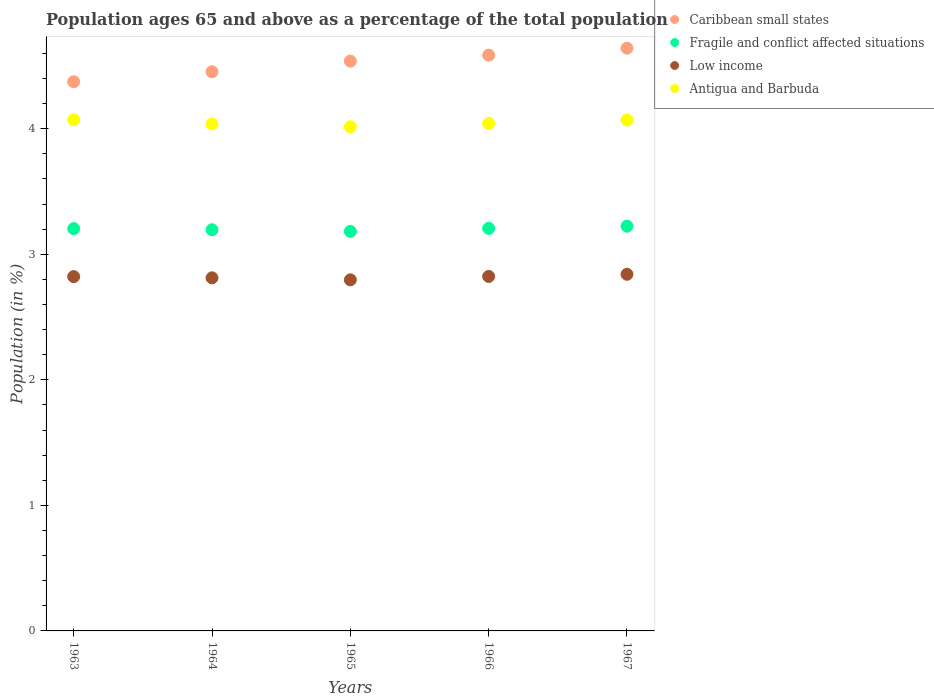How many different coloured dotlines are there?
Make the answer very short. 4. Is the number of dotlines equal to the number of legend labels?
Your answer should be compact. Yes. What is the percentage of the population ages 65 and above in Fragile and conflict affected situations in 1966?
Provide a succinct answer. 3.21. Across all years, what is the maximum percentage of the population ages 65 and above in Low income?
Your answer should be very brief. 2.84. Across all years, what is the minimum percentage of the population ages 65 and above in Caribbean small states?
Offer a terse response. 4.37. In which year was the percentage of the population ages 65 and above in Fragile and conflict affected situations maximum?
Your answer should be very brief. 1967. In which year was the percentage of the population ages 65 and above in Antigua and Barbuda minimum?
Provide a short and direct response. 1965. What is the total percentage of the population ages 65 and above in Caribbean small states in the graph?
Make the answer very short. 22.59. What is the difference between the percentage of the population ages 65 and above in Fragile and conflict affected situations in 1963 and that in 1966?
Provide a short and direct response. -0. What is the difference between the percentage of the population ages 65 and above in Caribbean small states in 1966 and the percentage of the population ages 65 and above in Fragile and conflict affected situations in 1965?
Offer a terse response. 1.4. What is the average percentage of the population ages 65 and above in Low income per year?
Keep it short and to the point. 2.82. In the year 1966, what is the difference between the percentage of the population ages 65 and above in Caribbean small states and percentage of the population ages 65 and above in Fragile and conflict affected situations?
Ensure brevity in your answer.  1.38. In how many years, is the percentage of the population ages 65 and above in Antigua and Barbuda greater than 3.2?
Your response must be concise. 5. What is the ratio of the percentage of the population ages 65 and above in Antigua and Barbuda in 1963 to that in 1967?
Provide a short and direct response. 1. Is the percentage of the population ages 65 and above in Fragile and conflict affected situations in 1964 less than that in 1966?
Keep it short and to the point. Yes. What is the difference between the highest and the second highest percentage of the population ages 65 and above in Caribbean small states?
Your response must be concise. 0.06. What is the difference between the highest and the lowest percentage of the population ages 65 and above in Fragile and conflict affected situations?
Your response must be concise. 0.04. In how many years, is the percentage of the population ages 65 and above in Low income greater than the average percentage of the population ages 65 and above in Low income taken over all years?
Provide a short and direct response. 3. Is the sum of the percentage of the population ages 65 and above in Fragile and conflict affected situations in 1964 and 1965 greater than the maximum percentage of the population ages 65 and above in Antigua and Barbuda across all years?
Provide a succinct answer. Yes. Is it the case that in every year, the sum of the percentage of the population ages 65 and above in Fragile and conflict affected situations and percentage of the population ages 65 and above in Antigua and Barbuda  is greater than the percentage of the population ages 65 and above in Caribbean small states?
Make the answer very short. Yes. Is the percentage of the population ages 65 and above in Fragile and conflict affected situations strictly greater than the percentage of the population ages 65 and above in Caribbean small states over the years?
Make the answer very short. No. Is the percentage of the population ages 65 and above in Caribbean small states strictly less than the percentage of the population ages 65 and above in Antigua and Barbuda over the years?
Your answer should be very brief. No. Are the values on the major ticks of Y-axis written in scientific E-notation?
Provide a succinct answer. No. Does the graph contain grids?
Your answer should be compact. No. Where does the legend appear in the graph?
Offer a terse response. Top right. How many legend labels are there?
Your answer should be very brief. 4. What is the title of the graph?
Your answer should be compact. Population ages 65 and above as a percentage of the total population. What is the label or title of the X-axis?
Provide a short and direct response. Years. What is the Population (in %) in Caribbean small states in 1963?
Provide a succinct answer. 4.37. What is the Population (in %) of Fragile and conflict affected situations in 1963?
Give a very brief answer. 3.2. What is the Population (in %) in Low income in 1963?
Provide a succinct answer. 2.82. What is the Population (in %) in Antigua and Barbuda in 1963?
Your answer should be compact. 4.07. What is the Population (in %) in Caribbean small states in 1964?
Offer a terse response. 4.45. What is the Population (in %) in Fragile and conflict affected situations in 1964?
Provide a succinct answer. 3.2. What is the Population (in %) of Low income in 1964?
Keep it short and to the point. 2.81. What is the Population (in %) of Antigua and Barbuda in 1964?
Offer a very short reply. 4.04. What is the Population (in %) in Caribbean small states in 1965?
Give a very brief answer. 4.54. What is the Population (in %) in Fragile and conflict affected situations in 1965?
Make the answer very short. 3.18. What is the Population (in %) in Low income in 1965?
Your answer should be very brief. 2.8. What is the Population (in %) in Antigua and Barbuda in 1965?
Ensure brevity in your answer.  4.01. What is the Population (in %) in Caribbean small states in 1966?
Provide a short and direct response. 4.59. What is the Population (in %) of Fragile and conflict affected situations in 1966?
Give a very brief answer. 3.21. What is the Population (in %) in Low income in 1966?
Offer a very short reply. 2.82. What is the Population (in %) of Antigua and Barbuda in 1966?
Your response must be concise. 4.04. What is the Population (in %) in Caribbean small states in 1967?
Keep it short and to the point. 4.64. What is the Population (in %) in Fragile and conflict affected situations in 1967?
Offer a very short reply. 3.22. What is the Population (in %) of Low income in 1967?
Keep it short and to the point. 2.84. What is the Population (in %) in Antigua and Barbuda in 1967?
Make the answer very short. 4.07. Across all years, what is the maximum Population (in %) in Caribbean small states?
Offer a terse response. 4.64. Across all years, what is the maximum Population (in %) of Fragile and conflict affected situations?
Your answer should be very brief. 3.22. Across all years, what is the maximum Population (in %) in Low income?
Ensure brevity in your answer.  2.84. Across all years, what is the maximum Population (in %) in Antigua and Barbuda?
Your response must be concise. 4.07. Across all years, what is the minimum Population (in %) of Caribbean small states?
Keep it short and to the point. 4.37. Across all years, what is the minimum Population (in %) of Fragile and conflict affected situations?
Ensure brevity in your answer.  3.18. Across all years, what is the minimum Population (in %) in Low income?
Ensure brevity in your answer.  2.8. Across all years, what is the minimum Population (in %) in Antigua and Barbuda?
Provide a short and direct response. 4.01. What is the total Population (in %) of Caribbean small states in the graph?
Make the answer very short. 22.59. What is the total Population (in %) in Fragile and conflict affected situations in the graph?
Offer a terse response. 16.01. What is the total Population (in %) in Low income in the graph?
Keep it short and to the point. 14.09. What is the total Population (in %) of Antigua and Barbuda in the graph?
Your answer should be compact. 20.23. What is the difference between the Population (in %) of Caribbean small states in 1963 and that in 1964?
Provide a short and direct response. -0.08. What is the difference between the Population (in %) of Fragile and conflict affected situations in 1963 and that in 1964?
Offer a terse response. 0.01. What is the difference between the Population (in %) of Low income in 1963 and that in 1964?
Give a very brief answer. 0.01. What is the difference between the Population (in %) in Antigua and Barbuda in 1963 and that in 1964?
Ensure brevity in your answer.  0.03. What is the difference between the Population (in %) in Caribbean small states in 1963 and that in 1965?
Your response must be concise. -0.16. What is the difference between the Population (in %) of Fragile and conflict affected situations in 1963 and that in 1965?
Offer a very short reply. 0.02. What is the difference between the Population (in %) of Low income in 1963 and that in 1965?
Provide a succinct answer. 0.03. What is the difference between the Population (in %) in Antigua and Barbuda in 1963 and that in 1965?
Provide a short and direct response. 0.06. What is the difference between the Population (in %) of Caribbean small states in 1963 and that in 1966?
Your answer should be compact. -0.21. What is the difference between the Population (in %) in Fragile and conflict affected situations in 1963 and that in 1966?
Keep it short and to the point. -0. What is the difference between the Population (in %) of Low income in 1963 and that in 1966?
Make the answer very short. -0. What is the difference between the Population (in %) of Antigua and Barbuda in 1963 and that in 1966?
Offer a terse response. 0.03. What is the difference between the Population (in %) in Caribbean small states in 1963 and that in 1967?
Your response must be concise. -0.27. What is the difference between the Population (in %) in Fragile and conflict affected situations in 1963 and that in 1967?
Make the answer very short. -0.02. What is the difference between the Population (in %) of Low income in 1963 and that in 1967?
Provide a succinct answer. -0.02. What is the difference between the Population (in %) of Caribbean small states in 1964 and that in 1965?
Offer a very short reply. -0.08. What is the difference between the Population (in %) of Fragile and conflict affected situations in 1964 and that in 1965?
Provide a succinct answer. 0.01. What is the difference between the Population (in %) of Low income in 1964 and that in 1965?
Provide a succinct answer. 0.02. What is the difference between the Population (in %) in Antigua and Barbuda in 1964 and that in 1965?
Offer a terse response. 0.02. What is the difference between the Population (in %) in Caribbean small states in 1964 and that in 1966?
Make the answer very short. -0.13. What is the difference between the Population (in %) of Fragile and conflict affected situations in 1964 and that in 1966?
Give a very brief answer. -0.01. What is the difference between the Population (in %) of Low income in 1964 and that in 1966?
Your response must be concise. -0.01. What is the difference between the Population (in %) of Antigua and Barbuda in 1964 and that in 1966?
Ensure brevity in your answer.  -0. What is the difference between the Population (in %) of Caribbean small states in 1964 and that in 1967?
Your answer should be very brief. -0.19. What is the difference between the Population (in %) in Fragile and conflict affected situations in 1964 and that in 1967?
Provide a succinct answer. -0.03. What is the difference between the Population (in %) in Low income in 1964 and that in 1967?
Make the answer very short. -0.03. What is the difference between the Population (in %) in Antigua and Barbuda in 1964 and that in 1967?
Give a very brief answer. -0.03. What is the difference between the Population (in %) in Caribbean small states in 1965 and that in 1966?
Ensure brevity in your answer.  -0.05. What is the difference between the Population (in %) in Fragile and conflict affected situations in 1965 and that in 1966?
Offer a terse response. -0.02. What is the difference between the Population (in %) of Low income in 1965 and that in 1966?
Your response must be concise. -0.03. What is the difference between the Population (in %) of Antigua and Barbuda in 1965 and that in 1966?
Your response must be concise. -0.03. What is the difference between the Population (in %) in Caribbean small states in 1965 and that in 1967?
Keep it short and to the point. -0.1. What is the difference between the Population (in %) of Fragile and conflict affected situations in 1965 and that in 1967?
Make the answer very short. -0.04. What is the difference between the Population (in %) of Low income in 1965 and that in 1967?
Your answer should be very brief. -0.04. What is the difference between the Population (in %) of Antigua and Barbuda in 1965 and that in 1967?
Provide a short and direct response. -0.05. What is the difference between the Population (in %) of Caribbean small states in 1966 and that in 1967?
Your answer should be very brief. -0.06. What is the difference between the Population (in %) in Fragile and conflict affected situations in 1966 and that in 1967?
Provide a succinct answer. -0.02. What is the difference between the Population (in %) in Low income in 1966 and that in 1967?
Offer a very short reply. -0.02. What is the difference between the Population (in %) in Antigua and Barbuda in 1966 and that in 1967?
Give a very brief answer. -0.03. What is the difference between the Population (in %) in Caribbean small states in 1963 and the Population (in %) in Fragile and conflict affected situations in 1964?
Give a very brief answer. 1.18. What is the difference between the Population (in %) of Caribbean small states in 1963 and the Population (in %) of Low income in 1964?
Keep it short and to the point. 1.56. What is the difference between the Population (in %) in Caribbean small states in 1963 and the Population (in %) in Antigua and Barbuda in 1964?
Provide a short and direct response. 0.34. What is the difference between the Population (in %) in Fragile and conflict affected situations in 1963 and the Population (in %) in Low income in 1964?
Your response must be concise. 0.39. What is the difference between the Population (in %) in Fragile and conflict affected situations in 1963 and the Population (in %) in Antigua and Barbuda in 1964?
Your response must be concise. -0.83. What is the difference between the Population (in %) of Low income in 1963 and the Population (in %) of Antigua and Barbuda in 1964?
Make the answer very short. -1.22. What is the difference between the Population (in %) in Caribbean small states in 1963 and the Population (in %) in Fragile and conflict affected situations in 1965?
Keep it short and to the point. 1.19. What is the difference between the Population (in %) of Caribbean small states in 1963 and the Population (in %) of Low income in 1965?
Make the answer very short. 1.58. What is the difference between the Population (in %) of Caribbean small states in 1963 and the Population (in %) of Antigua and Barbuda in 1965?
Keep it short and to the point. 0.36. What is the difference between the Population (in %) of Fragile and conflict affected situations in 1963 and the Population (in %) of Low income in 1965?
Provide a succinct answer. 0.41. What is the difference between the Population (in %) of Fragile and conflict affected situations in 1963 and the Population (in %) of Antigua and Barbuda in 1965?
Provide a succinct answer. -0.81. What is the difference between the Population (in %) of Low income in 1963 and the Population (in %) of Antigua and Barbuda in 1965?
Keep it short and to the point. -1.19. What is the difference between the Population (in %) in Caribbean small states in 1963 and the Population (in %) in Fragile and conflict affected situations in 1966?
Keep it short and to the point. 1.17. What is the difference between the Population (in %) of Caribbean small states in 1963 and the Population (in %) of Low income in 1966?
Provide a succinct answer. 1.55. What is the difference between the Population (in %) of Caribbean small states in 1963 and the Population (in %) of Antigua and Barbuda in 1966?
Your answer should be very brief. 0.33. What is the difference between the Population (in %) in Fragile and conflict affected situations in 1963 and the Population (in %) in Low income in 1966?
Your answer should be very brief. 0.38. What is the difference between the Population (in %) in Fragile and conflict affected situations in 1963 and the Population (in %) in Antigua and Barbuda in 1966?
Make the answer very short. -0.84. What is the difference between the Population (in %) in Low income in 1963 and the Population (in %) in Antigua and Barbuda in 1966?
Give a very brief answer. -1.22. What is the difference between the Population (in %) of Caribbean small states in 1963 and the Population (in %) of Fragile and conflict affected situations in 1967?
Provide a succinct answer. 1.15. What is the difference between the Population (in %) of Caribbean small states in 1963 and the Population (in %) of Low income in 1967?
Ensure brevity in your answer.  1.53. What is the difference between the Population (in %) of Caribbean small states in 1963 and the Population (in %) of Antigua and Barbuda in 1967?
Your response must be concise. 0.3. What is the difference between the Population (in %) in Fragile and conflict affected situations in 1963 and the Population (in %) in Low income in 1967?
Your response must be concise. 0.36. What is the difference between the Population (in %) of Fragile and conflict affected situations in 1963 and the Population (in %) of Antigua and Barbuda in 1967?
Make the answer very short. -0.87. What is the difference between the Population (in %) of Low income in 1963 and the Population (in %) of Antigua and Barbuda in 1967?
Your answer should be very brief. -1.25. What is the difference between the Population (in %) in Caribbean small states in 1964 and the Population (in %) in Fragile and conflict affected situations in 1965?
Offer a very short reply. 1.27. What is the difference between the Population (in %) of Caribbean small states in 1964 and the Population (in %) of Low income in 1965?
Keep it short and to the point. 1.66. What is the difference between the Population (in %) of Caribbean small states in 1964 and the Population (in %) of Antigua and Barbuda in 1965?
Your response must be concise. 0.44. What is the difference between the Population (in %) in Fragile and conflict affected situations in 1964 and the Population (in %) in Low income in 1965?
Your answer should be compact. 0.4. What is the difference between the Population (in %) of Fragile and conflict affected situations in 1964 and the Population (in %) of Antigua and Barbuda in 1965?
Give a very brief answer. -0.82. What is the difference between the Population (in %) of Low income in 1964 and the Population (in %) of Antigua and Barbuda in 1965?
Offer a terse response. -1.2. What is the difference between the Population (in %) of Caribbean small states in 1964 and the Population (in %) of Fragile and conflict affected situations in 1966?
Make the answer very short. 1.25. What is the difference between the Population (in %) in Caribbean small states in 1964 and the Population (in %) in Low income in 1966?
Your answer should be compact. 1.63. What is the difference between the Population (in %) of Caribbean small states in 1964 and the Population (in %) of Antigua and Barbuda in 1966?
Your response must be concise. 0.41. What is the difference between the Population (in %) in Fragile and conflict affected situations in 1964 and the Population (in %) in Low income in 1966?
Your answer should be compact. 0.37. What is the difference between the Population (in %) of Fragile and conflict affected situations in 1964 and the Population (in %) of Antigua and Barbuda in 1966?
Provide a short and direct response. -0.85. What is the difference between the Population (in %) in Low income in 1964 and the Population (in %) in Antigua and Barbuda in 1966?
Give a very brief answer. -1.23. What is the difference between the Population (in %) of Caribbean small states in 1964 and the Population (in %) of Fragile and conflict affected situations in 1967?
Provide a succinct answer. 1.23. What is the difference between the Population (in %) of Caribbean small states in 1964 and the Population (in %) of Low income in 1967?
Provide a short and direct response. 1.61. What is the difference between the Population (in %) of Caribbean small states in 1964 and the Population (in %) of Antigua and Barbuda in 1967?
Your response must be concise. 0.38. What is the difference between the Population (in %) of Fragile and conflict affected situations in 1964 and the Population (in %) of Low income in 1967?
Offer a very short reply. 0.35. What is the difference between the Population (in %) in Fragile and conflict affected situations in 1964 and the Population (in %) in Antigua and Barbuda in 1967?
Your answer should be very brief. -0.87. What is the difference between the Population (in %) of Low income in 1964 and the Population (in %) of Antigua and Barbuda in 1967?
Offer a terse response. -1.26. What is the difference between the Population (in %) of Caribbean small states in 1965 and the Population (in %) of Fragile and conflict affected situations in 1966?
Your answer should be very brief. 1.33. What is the difference between the Population (in %) in Caribbean small states in 1965 and the Population (in %) in Low income in 1966?
Your answer should be compact. 1.71. What is the difference between the Population (in %) in Caribbean small states in 1965 and the Population (in %) in Antigua and Barbuda in 1966?
Make the answer very short. 0.5. What is the difference between the Population (in %) in Fragile and conflict affected situations in 1965 and the Population (in %) in Low income in 1966?
Offer a terse response. 0.36. What is the difference between the Population (in %) of Fragile and conflict affected situations in 1965 and the Population (in %) of Antigua and Barbuda in 1966?
Your answer should be very brief. -0.86. What is the difference between the Population (in %) in Low income in 1965 and the Population (in %) in Antigua and Barbuda in 1966?
Provide a succinct answer. -1.25. What is the difference between the Population (in %) of Caribbean small states in 1965 and the Population (in %) of Fragile and conflict affected situations in 1967?
Offer a very short reply. 1.31. What is the difference between the Population (in %) in Caribbean small states in 1965 and the Population (in %) in Low income in 1967?
Offer a terse response. 1.7. What is the difference between the Population (in %) of Caribbean small states in 1965 and the Population (in %) of Antigua and Barbuda in 1967?
Your response must be concise. 0.47. What is the difference between the Population (in %) in Fragile and conflict affected situations in 1965 and the Population (in %) in Low income in 1967?
Ensure brevity in your answer.  0.34. What is the difference between the Population (in %) of Fragile and conflict affected situations in 1965 and the Population (in %) of Antigua and Barbuda in 1967?
Your answer should be compact. -0.89. What is the difference between the Population (in %) of Low income in 1965 and the Population (in %) of Antigua and Barbuda in 1967?
Keep it short and to the point. -1.27. What is the difference between the Population (in %) of Caribbean small states in 1966 and the Population (in %) of Fragile and conflict affected situations in 1967?
Make the answer very short. 1.36. What is the difference between the Population (in %) of Caribbean small states in 1966 and the Population (in %) of Low income in 1967?
Keep it short and to the point. 1.75. What is the difference between the Population (in %) of Caribbean small states in 1966 and the Population (in %) of Antigua and Barbuda in 1967?
Ensure brevity in your answer.  0.52. What is the difference between the Population (in %) of Fragile and conflict affected situations in 1966 and the Population (in %) of Low income in 1967?
Ensure brevity in your answer.  0.37. What is the difference between the Population (in %) of Fragile and conflict affected situations in 1966 and the Population (in %) of Antigua and Barbuda in 1967?
Your answer should be very brief. -0.86. What is the difference between the Population (in %) in Low income in 1966 and the Population (in %) in Antigua and Barbuda in 1967?
Your response must be concise. -1.25. What is the average Population (in %) of Caribbean small states per year?
Your response must be concise. 4.52. What is the average Population (in %) in Fragile and conflict affected situations per year?
Keep it short and to the point. 3.2. What is the average Population (in %) in Low income per year?
Ensure brevity in your answer.  2.82. What is the average Population (in %) in Antigua and Barbuda per year?
Your answer should be compact. 4.05. In the year 1963, what is the difference between the Population (in %) of Caribbean small states and Population (in %) of Fragile and conflict affected situations?
Ensure brevity in your answer.  1.17. In the year 1963, what is the difference between the Population (in %) of Caribbean small states and Population (in %) of Low income?
Provide a succinct answer. 1.55. In the year 1963, what is the difference between the Population (in %) in Caribbean small states and Population (in %) in Antigua and Barbuda?
Offer a very short reply. 0.3. In the year 1963, what is the difference between the Population (in %) of Fragile and conflict affected situations and Population (in %) of Low income?
Offer a terse response. 0.38. In the year 1963, what is the difference between the Population (in %) of Fragile and conflict affected situations and Population (in %) of Antigua and Barbuda?
Make the answer very short. -0.87. In the year 1963, what is the difference between the Population (in %) in Low income and Population (in %) in Antigua and Barbuda?
Your answer should be very brief. -1.25. In the year 1964, what is the difference between the Population (in %) of Caribbean small states and Population (in %) of Fragile and conflict affected situations?
Make the answer very short. 1.26. In the year 1964, what is the difference between the Population (in %) in Caribbean small states and Population (in %) in Low income?
Your answer should be compact. 1.64. In the year 1964, what is the difference between the Population (in %) of Caribbean small states and Population (in %) of Antigua and Barbuda?
Provide a succinct answer. 0.42. In the year 1964, what is the difference between the Population (in %) in Fragile and conflict affected situations and Population (in %) in Low income?
Give a very brief answer. 0.38. In the year 1964, what is the difference between the Population (in %) of Fragile and conflict affected situations and Population (in %) of Antigua and Barbuda?
Your response must be concise. -0.84. In the year 1964, what is the difference between the Population (in %) of Low income and Population (in %) of Antigua and Barbuda?
Give a very brief answer. -1.23. In the year 1965, what is the difference between the Population (in %) of Caribbean small states and Population (in %) of Fragile and conflict affected situations?
Give a very brief answer. 1.36. In the year 1965, what is the difference between the Population (in %) in Caribbean small states and Population (in %) in Low income?
Make the answer very short. 1.74. In the year 1965, what is the difference between the Population (in %) of Caribbean small states and Population (in %) of Antigua and Barbuda?
Your answer should be very brief. 0.52. In the year 1965, what is the difference between the Population (in %) of Fragile and conflict affected situations and Population (in %) of Low income?
Provide a short and direct response. 0.39. In the year 1965, what is the difference between the Population (in %) in Fragile and conflict affected situations and Population (in %) in Antigua and Barbuda?
Your answer should be compact. -0.83. In the year 1965, what is the difference between the Population (in %) of Low income and Population (in %) of Antigua and Barbuda?
Offer a terse response. -1.22. In the year 1966, what is the difference between the Population (in %) in Caribbean small states and Population (in %) in Fragile and conflict affected situations?
Provide a succinct answer. 1.38. In the year 1966, what is the difference between the Population (in %) of Caribbean small states and Population (in %) of Low income?
Provide a succinct answer. 1.76. In the year 1966, what is the difference between the Population (in %) of Caribbean small states and Population (in %) of Antigua and Barbuda?
Keep it short and to the point. 0.54. In the year 1966, what is the difference between the Population (in %) of Fragile and conflict affected situations and Population (in %) of Low income?
Offer a very short reply. 0.38. In the year 1966, what is the difference between the Population (in %) in Fragile and conflict affected situations and Population (in %) in Antigua and Barbuda?
Ensure brevity in your answer.  -0.84. In the year 1966, what is the difference between the Population (in %) in Low income and Population (in %) in Antigua and Barbuda?
Make the answer very short. -1.22. In the year 1967, what is the difference between the Population (in %) of Caribbean small states and Population (in %) of Fragile and conflict affected situations?
Make the answer very short. 1.42. In the year 1967, what is the difference between the Population (in %) of Caribbean small states and Population (in %) of Low income?
Provide a succinct answer. 1.8. In the year 1967, what is the difference between the Population (in %) of Caribbean small states and Population (in %) of Antigua and Barbuda?
Your response must be concise. 0.57. In the year 1967, what is the difference between the Population (in %) in Fragile and conflict affected situations and Population (in %) in Low income?
Your response must be concise. 0.38. In the year 1967, what is the difference between the Population (in %) in Fragile and conflict affected situations and Population (in %) in Antigua and Barbuda?
Offer a very short reply. -0.85. In the year 1967, what is the difference between the Population (in %) of Low income and Population (in %) of Antigua and Barbuda?
Offer a terse response. -1.23. What is the ratio of the Population (in %) in Caribbean small states in 1963 to that in 1964?
Provide a short and direct response. 0.98. What is the ratio of the Population (in %) of Fragile and conflict affected situations in 1963 to that in 1964?
Offer a terse response. 1. What is the ratio of the Population (in %) in Low income in 1963 to that in 1964?
Ensure brevity in your answer.  1. What is the ratio of the Population (in %) in Antigua and Barbuda in 1963 to that in 1964?
Provide a short and direct response. 1.01. What is the ratio of the Population (in %) in Caribbean small states in 1963 to that in 1965?
Make the answer very short. 0.96. What is the ratio of the Population (in %) in Fragile and conflict affected situations in 1963 to that in 1965?
Your answer should be compact. 1.01. What is the ratio of the Population (in %) of Low income in 1963 to that in 1965?
Keep it short and to the point. 1.01. What is the ratio of the Population (in %) in Antigua and Barbuda in 1963 to that in 1965?
Your answer should be very brief. 1.01. What is the ratio of the Population (in %) of Caribbean small states in 1963 to that in 1966?
Give a very brief answer. 0.95. What is the ratio of the Population (in %) in Fragile and conflict affected situations in 1963 to that in 1966?
Provide a succinct answer. 1. What is the ratio of the Population (in %) of Low income in 1963 to that in 1966?
Offer a terse response. 1. What is the ratio of the Population (in %) of Antigua and Barbuda in 1963 to that in 1966?
Offer a very short reply. 1.01. What is the ratio of the Population (in %) in Caribbean small states in 1963 to that in 1967?
Make the answer very short. 0.94. What is the ratio of the Population (in %) of Fragile and conflict affected situations in 1963 to that in 1967?
Your answer should be very brief. 0.99. What is the ratio of the Population (in %) of Low income in 1963 to that in 1967?
Give a very brief answer. 0.99. What is the ratio of the Population (in %) of Antigua and Barbuda in 1963 to that in 1967?
Make the answer very short. 1. What is the ratio of the Population (in %) of Caribbean small states in 1964 to that in 1965?
Give a very brief answer. 0.98. What is the ratio of the Population (in %) of Low income in 1964 to that in 1965?
Keep it short and to the point. 1.01. What is the ratio of the Population (in %) in Caribbean small states in 1964 to that in 1966?
Your answer should be compact. 0.97. What is the ratio of the Population (in %) of Fragile and conflict affected situations in 1964 to that in 1966?
Provide a short and direct response. 1. What is the ratio of the Population (in %) of Low income in 1964 to that in 1966?
Give a very brief answer. 1. What is the ratio of the Population (in %) in Caribbean small states in 1964 to that in 1967?
Your answer should be very brief. 0.96. What is the ratio of the Population (in %) of Caribbean small states in 1965 to that in 1967?
Give a very brief answer. 0.98. What is the ratio of the Population (in %) of Fragile and conflict affected situations in 1965 to that in 1967?
Your answer should be very brief. 0.99. What is the ratio of the Population (in %) in Low income in 1965 to that in 1967?
Your answer should be very brief. 0.98. What is the ratio of the Population (in %) of Antigua and Barbuda in 1965 to that in 1967?
Keep it short and to the point. 0.99. What is the ratio of the Population (in %) of Fragile and conflict affected situations in 1966 to that in 1967?
Your response must be concise. 0.99. What is the ratio of the Population (in %) of Low income in 1966 to that in 1967?
Make the answer very short. 0.99. What is the ratio of the Population (in %) in Antigua and Barbuda in 1966 to that in 1967?
Make the answer very short. 0.99. What is the difference between the highest and the second highest Population (in %) in Caribbean small states?
Make the answer very short. 0.06. What is the difference between the highest and the second highest Population (in %) in Fragile and conflict affected situations?
Provide a short and direct response. 0.02. What is the difference between the highest and the second highest Population (in %) of Low income?
Make the answer very short. 0.02. What is the difference between the highest and the lowest Population (in %) in Caribbean small states?
Ensure brevity in your answer.  0.27. What is the difference between the highest and the lowest Population (in %) of Fragile and conflict affected situations?
Provide a succinct answer. 0.04. What is the difference between the highest and the lowest Population (in %) in Low income?
Offer a very short reply. 0.04. What is the difference between the highest and the lowest Population (in %) of Antigua and Barbuda?
Offer a terse response. 0.06. 